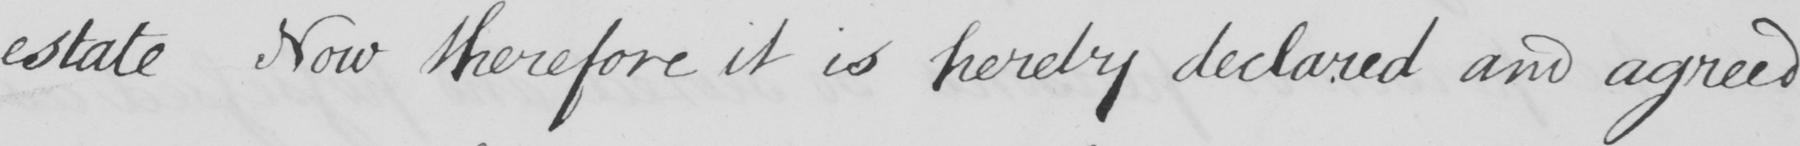What text is written in this handwritten line? estate Now therefore it is hereby declared and agreed 